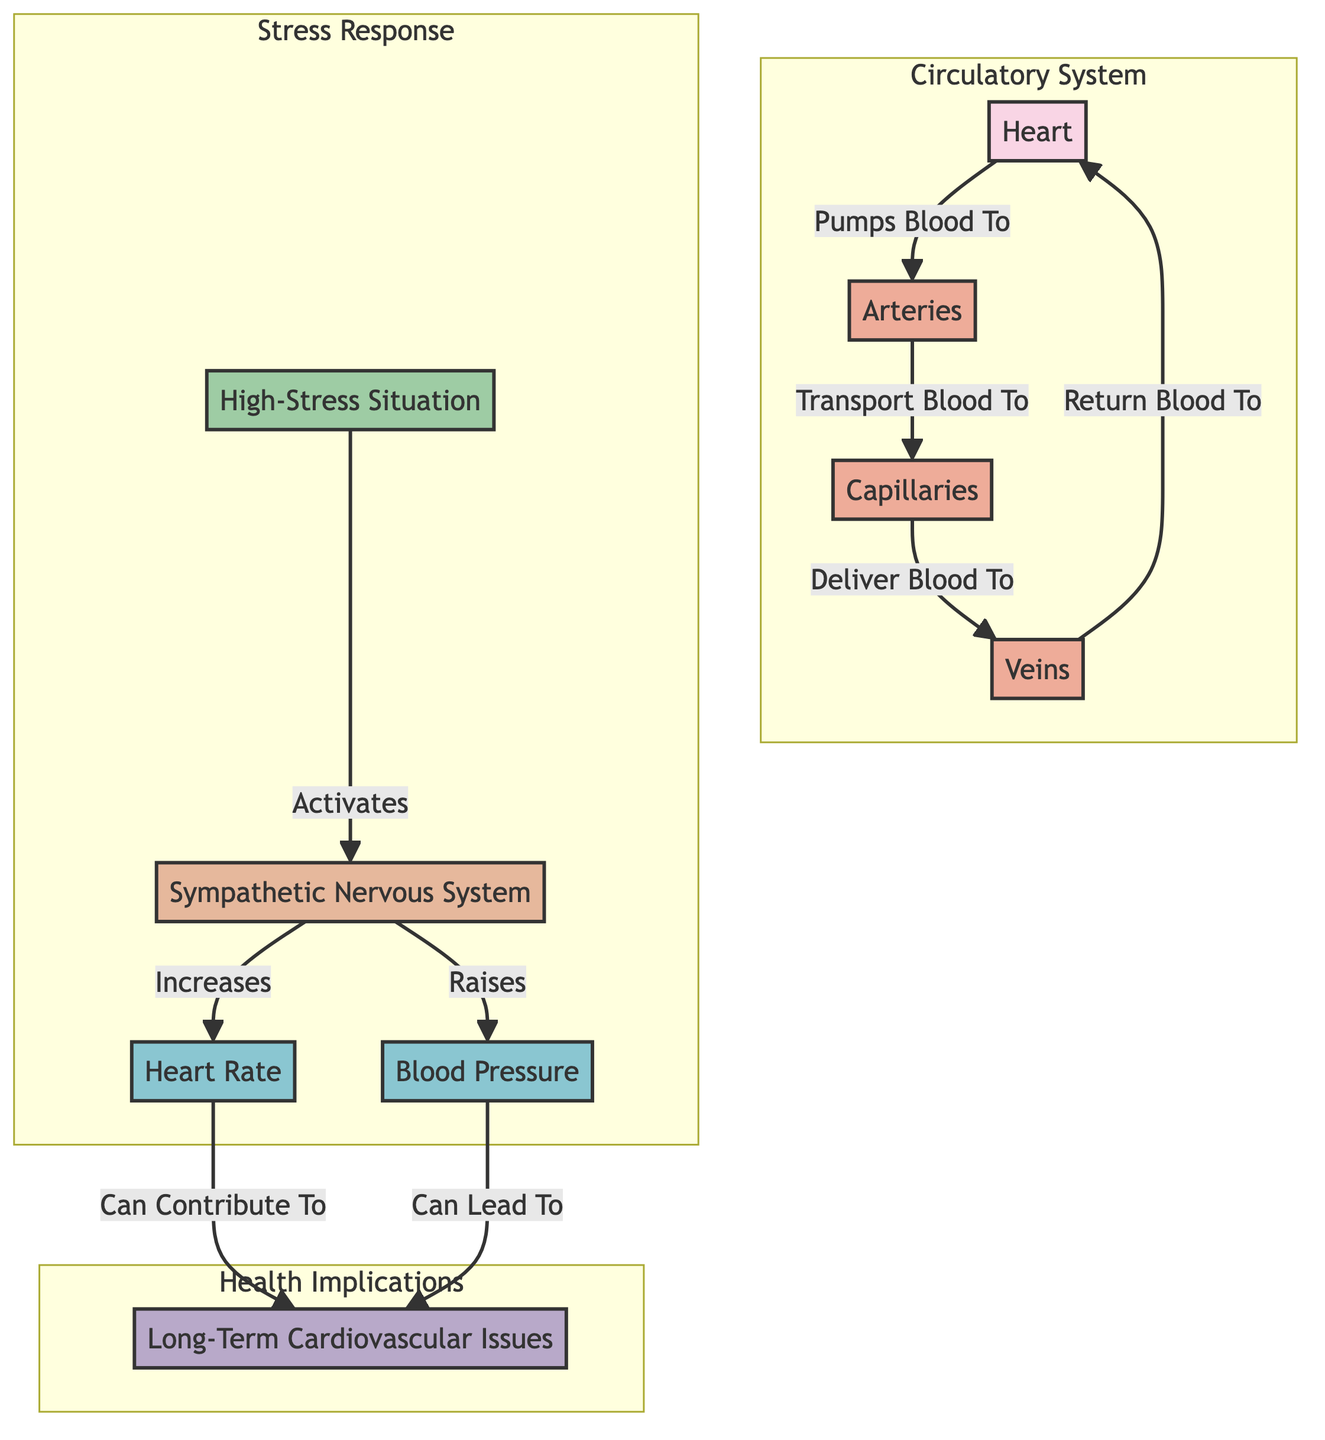What organ is at the center of the circulatory system? The diagram clearly identifies the heart as the central organ of the circulatory system, as it is depicted at the core of the circulatory network.
Answer: Heart Which vessels carry blood away from the heart? The diagram shows that the arteries are responsible for transporting blood away from the heart, illustrated by the directed edge leading from the heart to the arteries.
Answer: Arteries How does the sympathetic nervous system affect heart rate? The diagram indicates a direct influence, stating that the sympathetic nervous system increases heart rate, as seen from the connecting edge labeled "Increases" pointing to the heart rate node.
Answer: Increases What triggers the activation of the sympathetic nervous system? The diagram specifies that a high-stress situation activates the sympathetic nervous system, as represented by the edge labeled "Activates" pointing from the situation to the SNS.
Answer: High-Stress Situation If blood pressure rises, what health issue can it potentially lead to? The diagram suggests that increased blood pressure can lead to long-term cardiovascular issues, as the directed edge indicates this relationship.
Answer: Long-Term Cardiovascular Issues What flows from veins back to the heart? The diagram provides a clear connection showing that veins are responsible for returning blood to the heart, as indicated by the directed edge from veins to heart.
Answer: Blood How many main components are in the "Circulatory System" subgraph? The "Circulatory System" subgraph includes four components: heart, arteries, veins, and capillaries, which can be counted directly in the visual grouping.
Answer: Four What is the effect of heart rate on long-term cardiovascular issues? The diagram illustrates that heart rate can contribute to long-term cardiovascular issues, highlighted by the edge labeled "Can Contribute To" linking heart rate to long-term issues.
Answer: Can Contribute To What system is activated during high-stress situations? The diagram indicates that the sympathetic nervous system (SNS) is activated during high-stress situations, as shown by the edge connecting the situation to the SNS.
Answer: Sympathetic Nervous System 